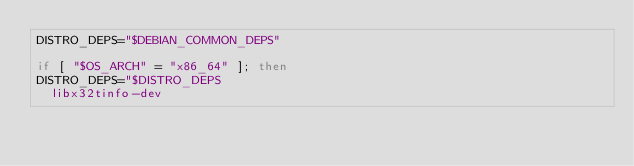Convert code to text. <code><loc_0><loc_0><loc_500><loc_500><_Bash_>DISTRO_DEPS="$DEBIAN_COMMON_DEPS"

if [ "$OS_ARCH" = "x86_64" ]; then
DISTRO_DEPS="$DISTRO_DEPS
	libx32tinfo-dev</code> 